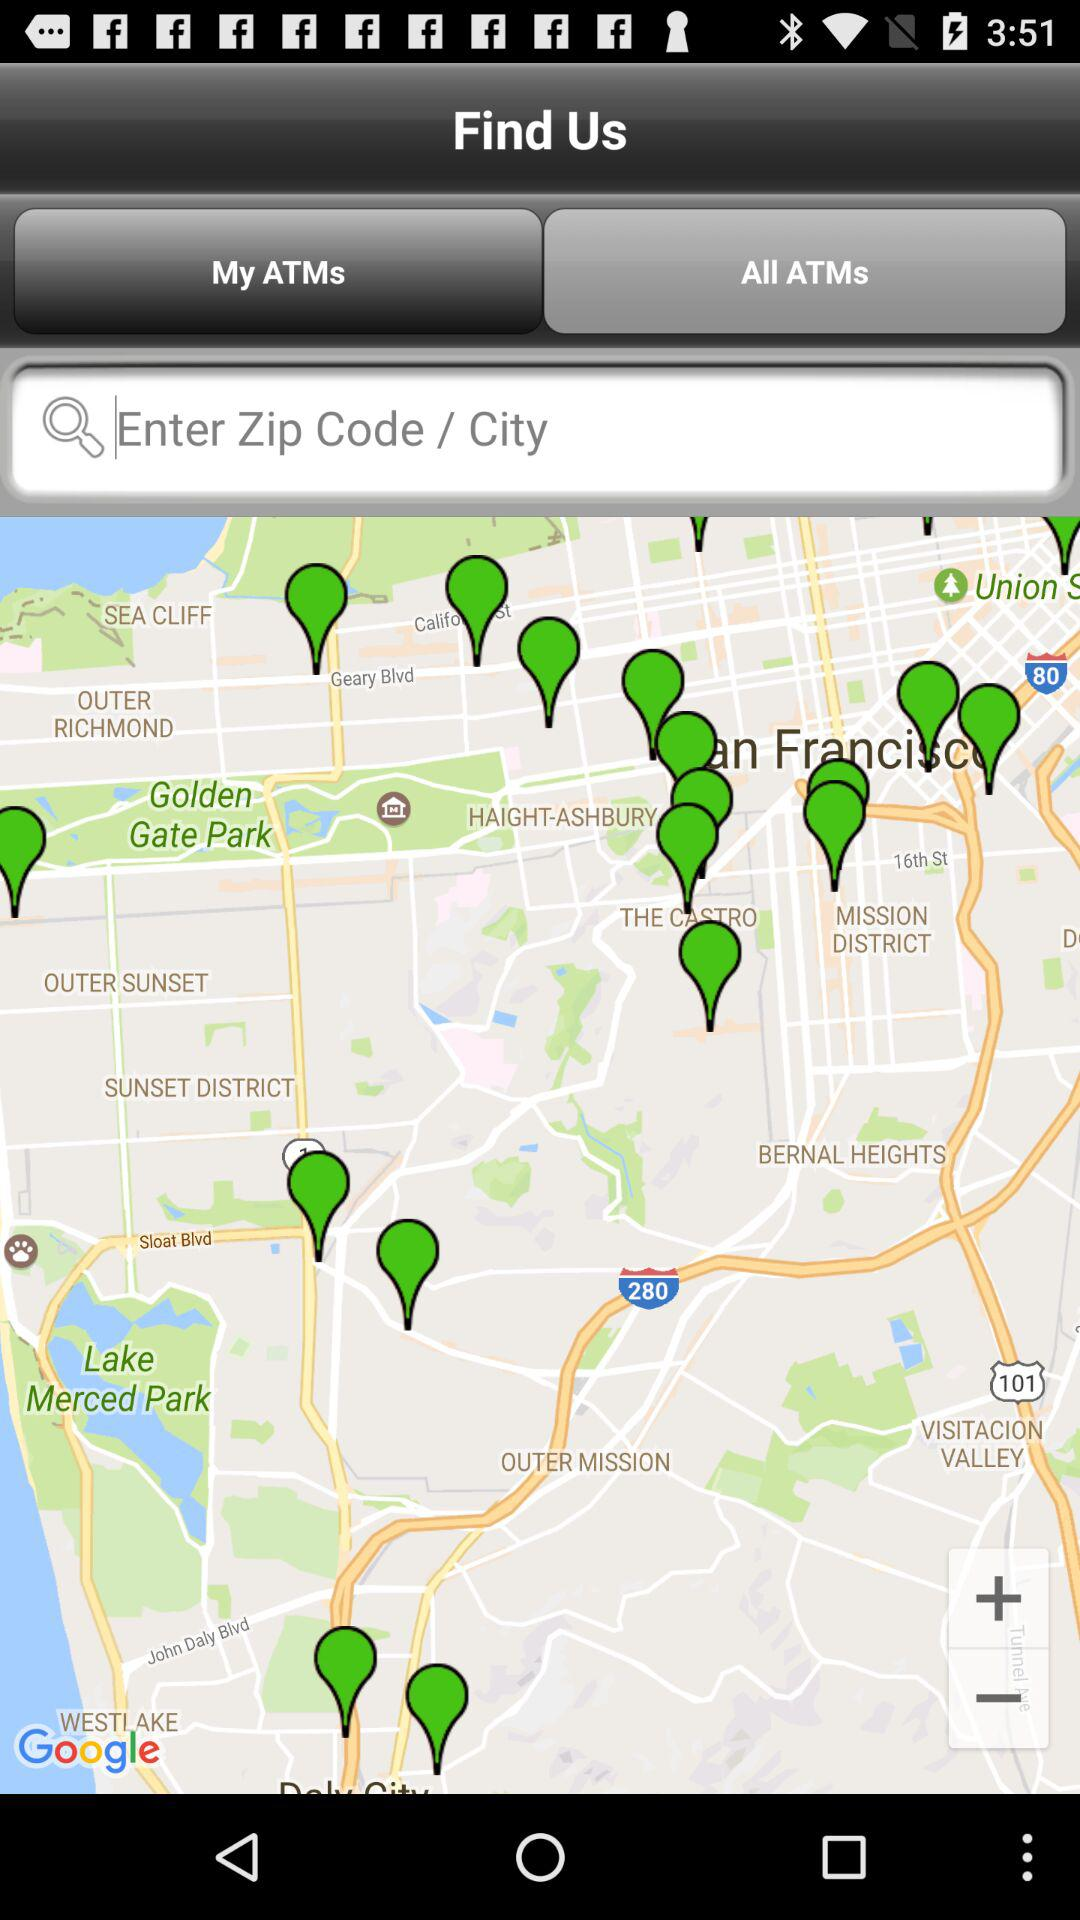What is the selected option to find us? The selected option is "My ATMs". 